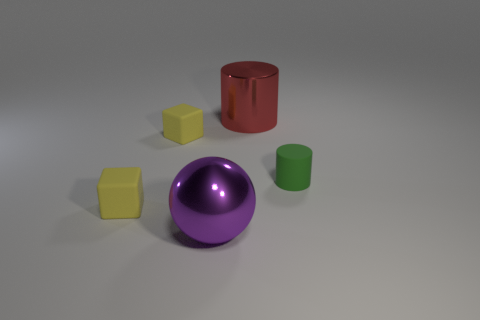Add 5 small yellow objects. How many objects exist? 10 Subtract 2 cylinders. How many cylinders are left? 0 Subtract all green cylinders. How many cylinders are left? 1 Subtract all cyan cylinders. Subtract all red spheres. How many cylinders are left? 2 Subtract all cyan blocks. How many red cylinders are left? 1 Subtract all big purple spheres. Subtract all large purple cylinders. How many objects are left? 4 Add 1 big shiny cylinders. How many big shiny cylinders are left? 2 Add 3 blocks. How many blocks exist? 5 Subtract 0 red balls. How many objects are left? 5 Subtract all cubes. How many objects are left? 3 